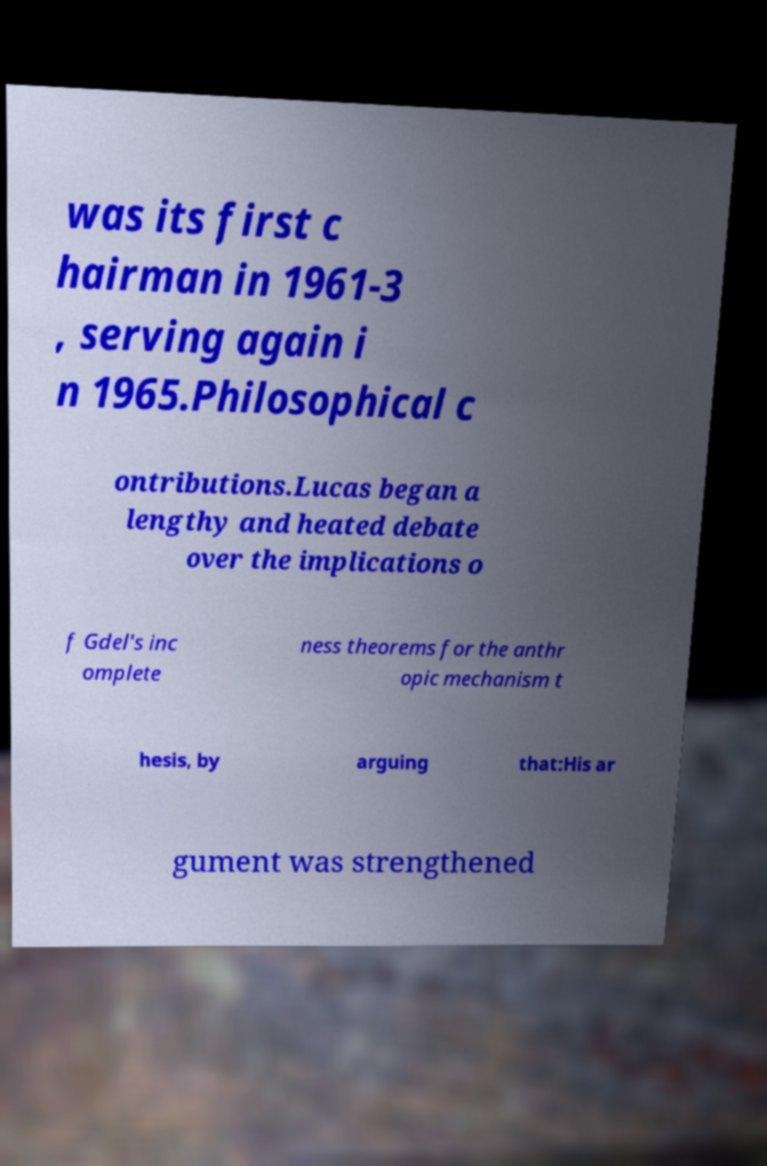Please read and relay the text visible in this image. What does it say? was its first c hairman in 1961-3 , serving again i n 1965.Philosophical c ontributions.Lucas began a lengthy and heated debate over the implications o f Gdel's inc omplete ness theorems for the anthr opic mechanism t hesis, by arguing that:His ar gument was strengthened 